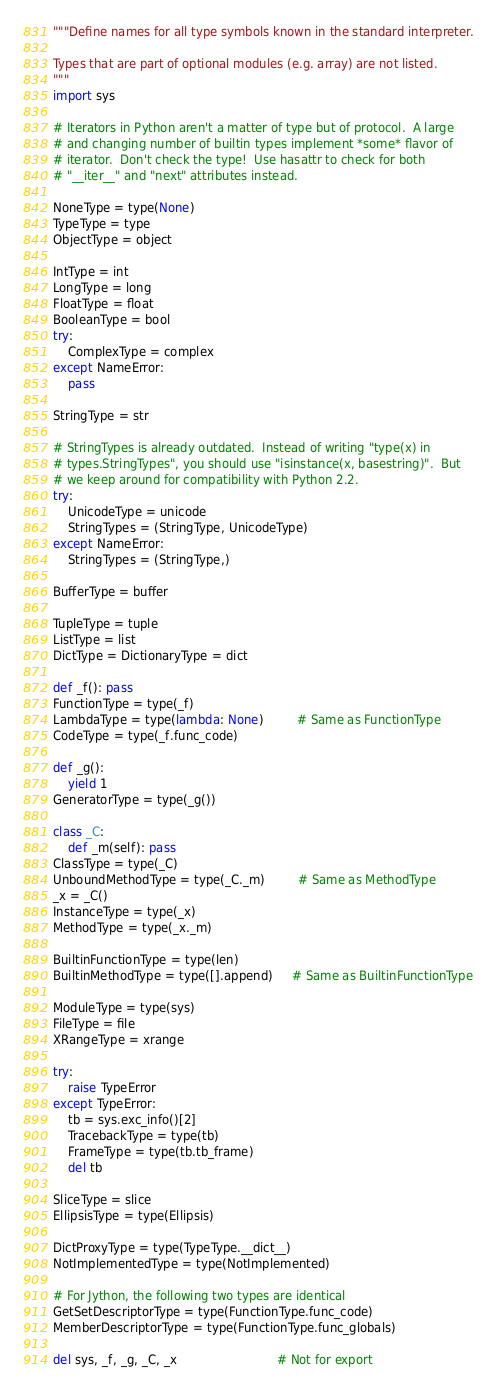Convert code to text. <code><loc_0><loc_0><loc_500><loc_500><_Python_>"""Define names for all type symbols known in the standard interpreter.

Types that are part of optional modules (e.g. array) are not listed.
"""
import sys

# Iterators in Python aren't a matter of type but of protocol.  A large
# and changing number of builtin types implement *some* flavor of
# iterator.  Don't check the type!  Use hasattr to check for both
# "__iter__" and "next" attributes instead.

NoneType = type(None)
TypeType = type
ObjectType = object

IntType = int
LongType = long
FloatType = float
BooleanType = bool
try:
    ComplexType = complex
except NameError:
    pass

StringType = str

# StringTypes is already outdated.  Instead of writing "type(x) in
# types.StringTypes", you should use "isinstance(x, basestring)".  But
# we keep around for compatibility with Python 2.2.
try:
    UnicodeType = unicode
    StringTypes = (StringType, UnicodeType)
except NameError:
    StringTypes = (StringType,)

BufferType = buffer

TupleType = tuple
ListType = list
DictType = DictionaryType = dict

def _f(): pass
FunctionType = type(_f)
LambdaType = type(lambda: None)         # Same as FunctionType
CodeType = type(_f.func_code)

def _g():
    yield 1
GeneratorType = type(_g())

class _C:
    def _m(self): pass
ClassType = type(_C)
UnboundMethodType = type(_C._m)         # Same as MethodType
_x = _C()
InstanceType = type(_x)
MethodType = type(_x._m)

BuiltinFunctionType = type(len)
BuiltinMethodType = type([].append)     # Same as BuiltinFunctionType

ModuleType = type(sys)
FileType = file
XRangeType = xrange

try:
    raise TypeError
except TypeError:
    tb = sys.exc_info()[2]
    TracebackType = type(tb)
    FrameType = type(tb.tb_frame)
    del tb

SliceType = slice
EllipsisType = type(Ellipsis)

DictProxyType = type(TypeType.__dict__)
NotImplementedType = type(NotImplemented)

# For Jython, the following two types are identical
GetSetDescriptorType = type(FunctionType.func_code)
MemberDescriptorType = type(FunctionType.func_globals)

del sys, _f, _g, _C, _x                           # Not for export
</code> 